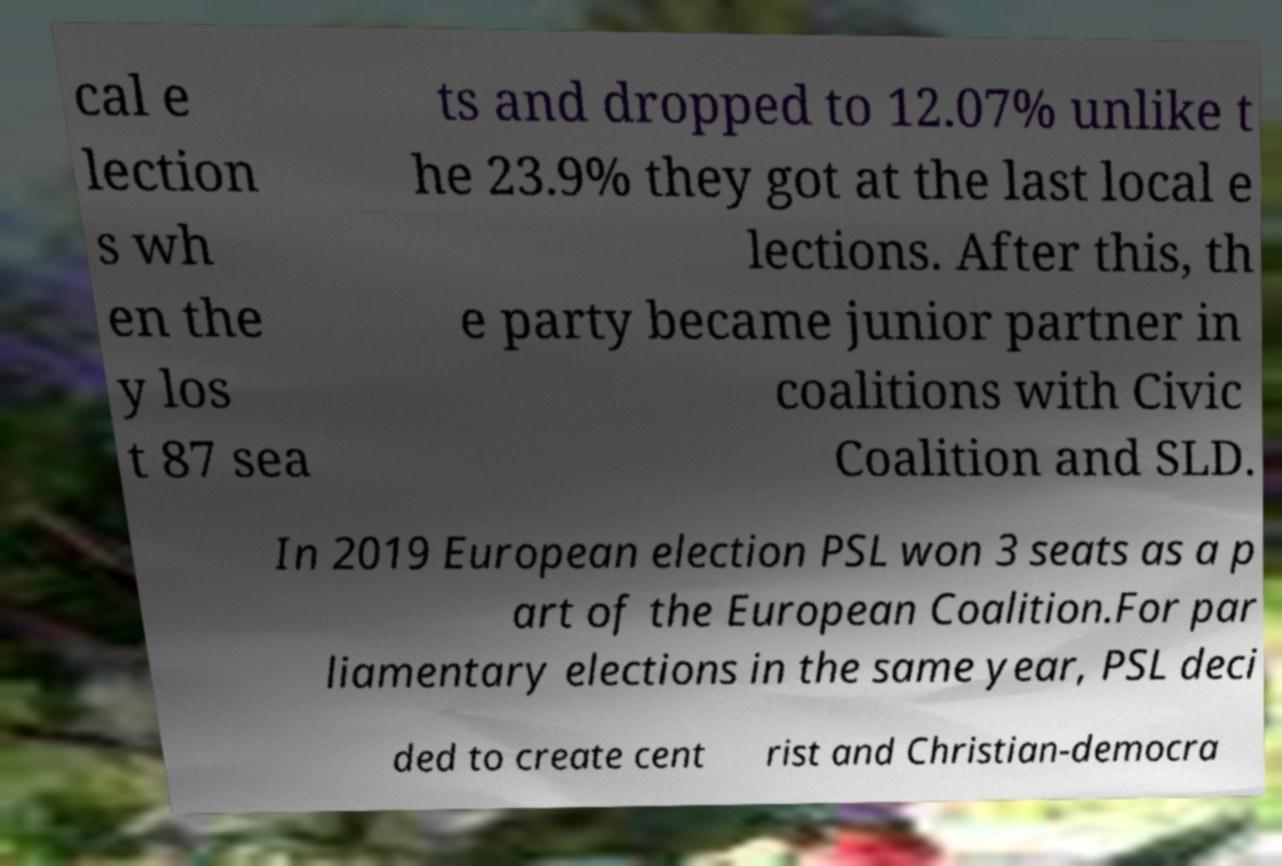There's text embedded in this image that I need extracted. Can you transcribe it verbatim? cal e lection s wh en the y los t 87 sea ts and dropped to 12.07% unlike t he 23.9% they got at the last local e lections. After this, th e party became junior partner in coalitions with Civic Coalition and SLD. In 2019 European election PSL won 3 seats as a p art of the European Coalition.For par liamentary elections in the same year, PSL deci ded to create cent rist and Christian-democra 